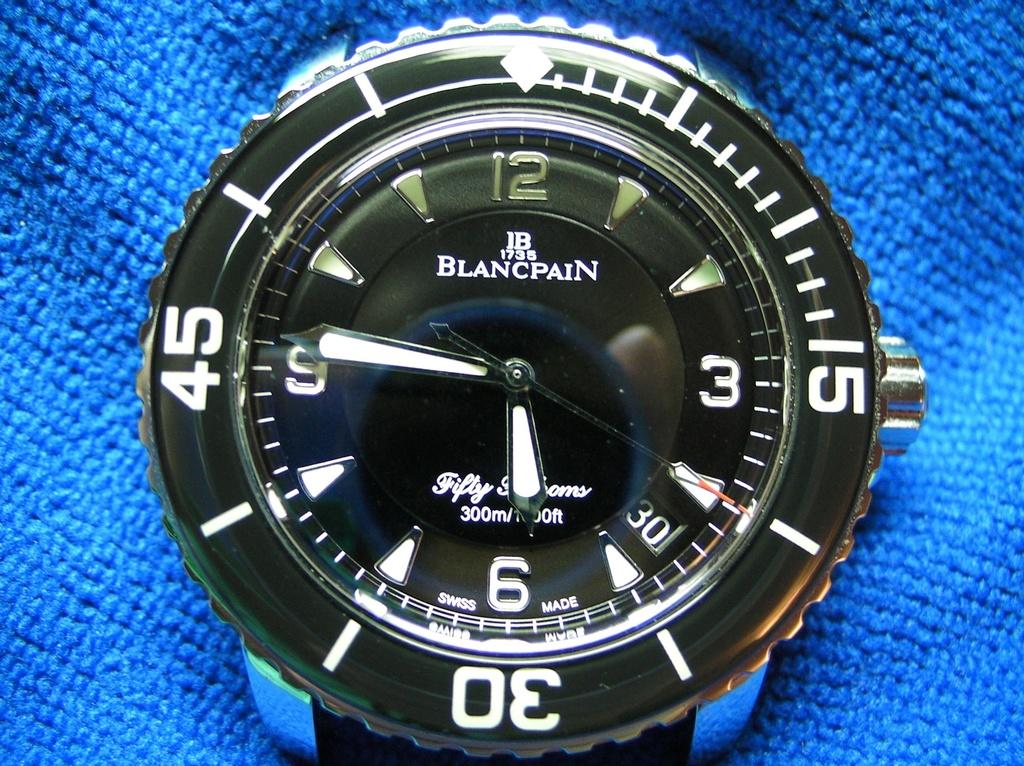<image>
Provide a brief description of the given image. A Blancpain watch face shows the time as 5:46 against a blue cloth background. 